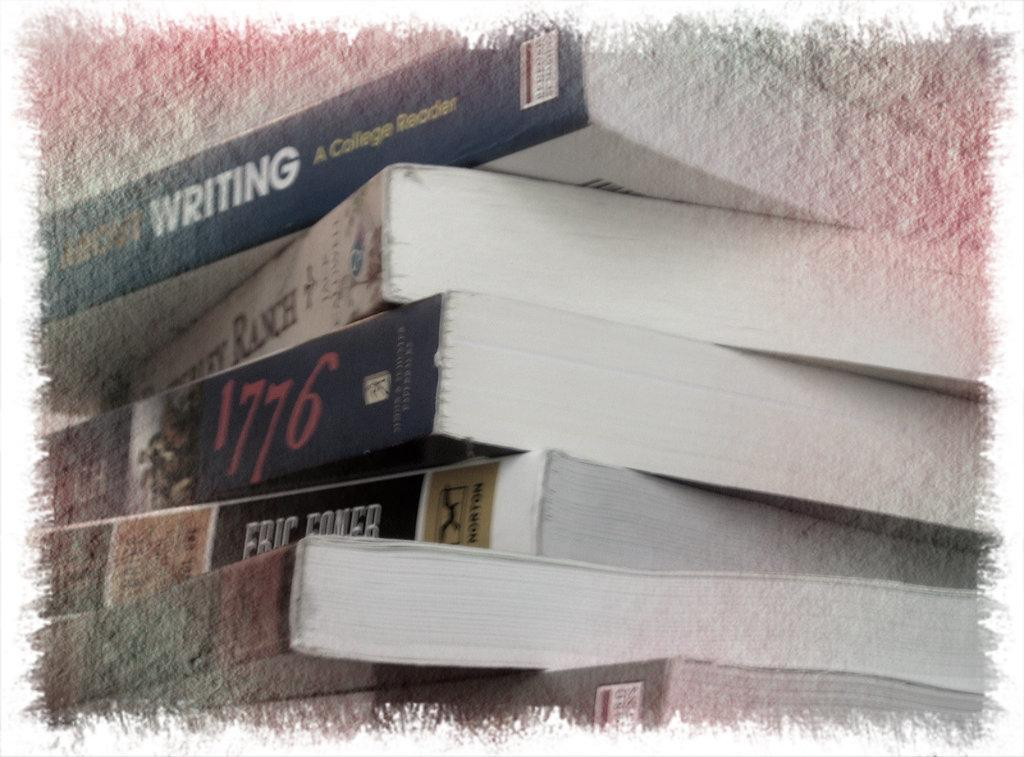<image>
Write a terse but informative summary of the picture. a pile of books including one entitled 1776 